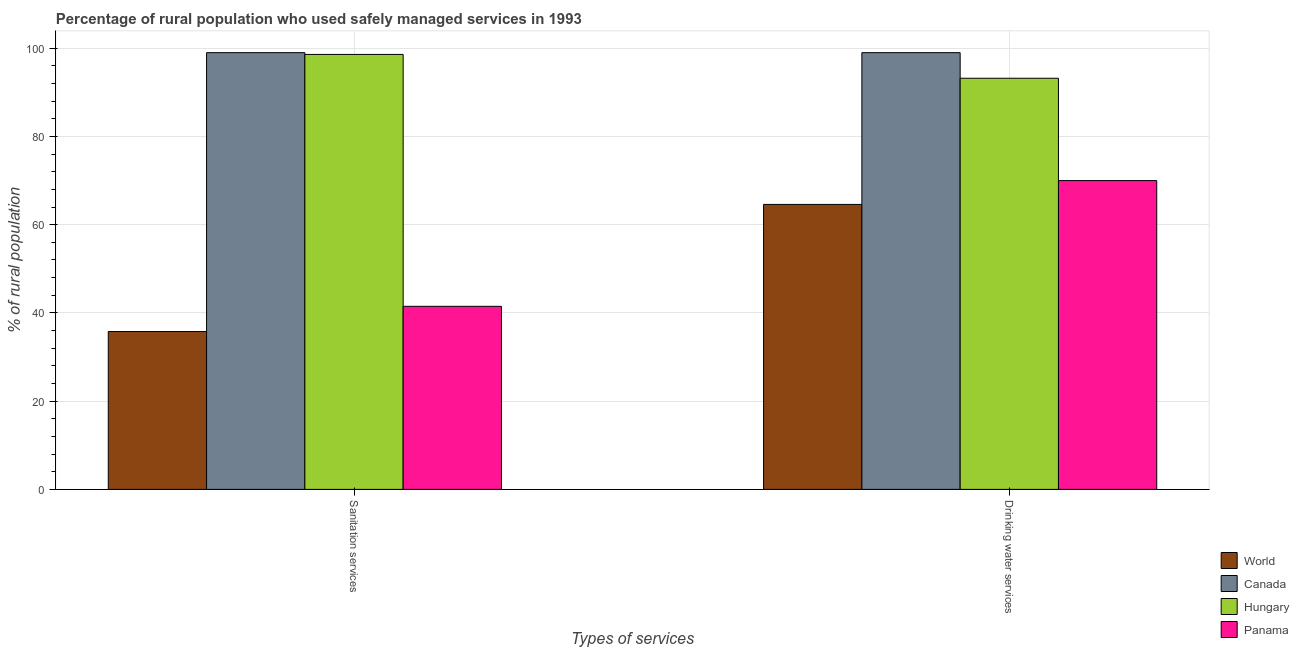Are the number of bars per tick equal to the number of legend labels?
Make the answer very short. Yes. Are the number of bars on each tick of the X-axis equal?
Your response must be concise. Yes. What is the label of the 2nd group of bars from the left?
Provide a short and direct response. Drinking water services. What is the percentage of rural population who used drinking water services in Panama?
Ensure brevity in your answer.  70. Across all countries, what is the maximum percentage of rural population who used sanitation services?
Your answer should be very brief. 99. Across all countries, what is the minimum percentage of rural population who used sanitation services?
Offer a terse response. 35.78. What is the total percentage of rural population who used sanitation services in the graph?
Your answer should be compact. 274.88. What is the difference between the percentage of rural population who used drinking water services in Hungary and that in World?
Keep it short and to the point. 28.6. What is the difference between the percentage of rural population who used drinking water services in World and the percentage of rural population who used sanitation services in Panama?
Offer a terse response. 23.1. What is the average percentage of rural population who used drinking water services per country?
Your answer should be very brief. 81.7. What is the difference between the percentage of rural population who used drinking water services and percentage of rural population who used sanitation services in Panama?
Ensure brevity in your answer.  28.5. What is the ratio of the percentage of rural population who used drinking water services in Canada to that in World?
Ensure brevity in your answer.  1.53. Is the percentage of rural population who used drinking water services in Canada less than that in Panama?
Ensure brevity in your answer.  No. In how many countries, is the percentage of rural population who used drinking water services greater than the average percentage of rural population who used drinking water services taken over all countries?
Offer a terse response. 2. What does the 1st bar from the left in Drinking water services represents?
Keep it short and to the point. World. What does the 3rd bar from the right in Sanitation services represents?
Your answer should be compact. Canada. How many bars are there?
Make the answer very short. 8. Are the values on the major ticks of Y-axis written in scientific E-notation?
Your answer should be very brief. No. Does the graph contain any zero values?
Offer a terse response. No. Where does the legend appear in the graph?
Your answer should be very brief. Bottom right. How many legend labels are there?
Ensure brevity in your answer.  4. What is the title of the graph?
Your answer should be compact. Percentage of rural population who used safely managed services in 1993. Does "Germany" appear as one of the legend labels in the graph?
Your answer should be very brief. No. What is the label or title of the X-axis?
Provide a succinct answer. Types of services. What is the label or title of the Y-axis?
Your answer should be compact. % of rural population. What is the % of rural population in World in Sanitation services?
Make the answer very short. 35.78. What is the % of rural population of Canada in Sanitation services?
Ensure brevity in your answer.  99. What is the % of rural population in Hungary in Sanitation services?
Ensure brevity in your answer.  98.6. What is the % of rural population of Panama in Sanitation services?
Give a very brief answer. 41.5. What is the % of rural population of World in Drinking water services?
Provide a short and direct response. 64.6. What is the % of rural population of Canada in Drinking water services?
Your answer should be compact. 99. What is the % of rural population of Hungary in Drinking water services?
Give a very brief answer. 93.2. What is the % of rural population in Panama in Drinking water services?
Your answer should be compact. 70. Across all Types of services, what is the maximum % of rural population in World?
Make the answer very short. 64.6. Across all Types of services, what is the maximum % of rural population in Canada?
Your answer should be very brief. 99. Across all Types of services, what is the maximum % of rural population of Hungary?
Offer a terse response. 98.6. Across all Types of services, what is the minimum % of rural population of World?
Provide a short and direct response. 35.78. Across all Types of services, what is the minimum % of rural population of Hungary?
Offer a terse response. 93.2. Across all Types of services, what is the minimum % of rural population of Panama?
Ensure brevity in your answer.  41.5. What is the total % of rural population in World in the graph?
Give a very brief answer. 100.38. What is the total % of rural population of Canada in the graph?
Your response must be concise. 198. What is the total % of rural population in Hungary in the graph?
Your answer should be very brief. 191.8. What is the total % of rural population in Panama in the graph?
Provide a short and direct response. 111.5. What is the difference between the % of rural population in World in Sanitation services and that in Drinking water services?
Make the answer very short. -28.81. What is the difference between the % of rural population in Hungary in Sanitation services and that in Drinking water services?
Give a very brief answer. 5.4. What is the difference between the % of rural population of Panama in Sanitation services and that in Drinking water services?
Provide a short and direct response. -28.5. What is the difference between the % of rural population in World in Sanitation services and the % of rural population in Canada in Drinking water services?
Your answer should be very brief. -63.22. What is the difference between the % of rural population of World in Sanitation services and the % of rural population of Hungary in Drinking water services?
Your answer should be very brief. -57.42. What is the difference between the % of rural population in World in Sanitation services and the % of rural population in Panama in Drinking water services?
Provide a succinct answer. -34.22. What is the difference between the % of rural population of Canada in Sanitation services and the % of rural population of Hungary in Drinking water services?
Your answer should be compact. 5.8. What is the difference between the % of rural population in Canada in Sanitation services and the % of rural population in Panama in Drinking water services?
Keep it short and to the point. 29. What is the difference between the % of rural population in Hungary in Sanitation services and the % of rural population in Panama in Drinking water services?
Ensure brevity in your answer.  28.6. What is the average % of rural population of World per Types of services?
Offer a very short reply. 50.19. What is the average % of rural population of Canada per Types of services?
Provide a short and direct response. 99. What is the average % of rural population of Hungary per Types of services?
Offer a terse response. 95.9. What is the average % of rural population of Panama per Types of services?
Provide a succinct answer. 55.75. What is the difference between the % of rural population in World and % of rural population in Canada in Sanitation services?
Your answer should be very brief. -63.22. What is the difference between the % of rural population in World and % of rural population in Hungary in Sanitation services?
Provide a short and direct response. -62.82. What is the difference between the % of rural population of World and % of rural population of Panama in Sanitation services?
Offer a very short reply. -5.72. What is the difference between the % of rural population in Canada and % of rural population in Panama in Sanitation services?
Keep it short and to the point. 57.5. What is the difference between the % of rural population of Hungary and % of rural population of Panama in Sanitation services?
Provide a succinct answer. 57.1. What is the difference between the % of rural population of World and % of rural population of Canada in Drinking water services?
Your answer should be compact. -34.4. What is the difference between the % of rural population in World and % of rural population in Hungary in Drinking water services?
Give a very brief answer. -28.6. What is the difference between the % of rural population in World and % of rural population in Panama in Drinking water services?
Keep it short and to the point. -5.4. What is the difference between the % of rural population in Canada and % of rural population in Panama in Drinking water services?
Your answer should be very brief. 29. What is the difference between the % of rural population of Hungary and % of rural population of Panama in Drinking water services?
Give a very brief answer. 23.2. What is the ratio of the % of rural population of World in Sanitation services to that in Drinking water services?
Offer a terse response. 0.55. What is the ratio of the % of rural population in Canada in Sanitation services to that in Drinking water services?
Offer a terse response. 1. What is the ratio of the % of rural population in Hungary in Sanitation services to that in Drinking water services?
Provide a short and direct response. 1.06. What is the ratio of the % of rural population in Panama in Sanitation services to that in Drinking water services?
Provide a succinct answer. 0.59. What is the difference between the highest and the second highest % of rural population in World?
Keep it short and to the point. 28.81. What is the difference between the highest and the second highest % of rural population of Canada?
Make the answer very short. 0. What is the difference between the highest and the second highest % of rural population of Hungary?
Ensure brevity in your answer.  5.4. What is the difference between the highest and the second highest % of rural population of Panama?
Keep it short and to the point. 28.5. What is the difference between the highest and the lowest % of rural population of World?
Your answer should be very brief. 28.81. What is the difference between the highest and the lowest % of rural population in Panama?
Provide a succinct answer. 28.5. 